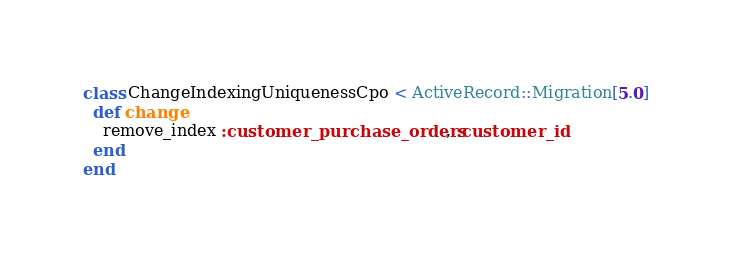<code> <loc_0><loc_0><loc_500><loc_500><_Ruby_>class ChangeIndexingUniquenessCpo < ActiveRecord::Migration[5.0]
  def change
    remove_index :customer_purchase_orders, :customer_id
  end
end
</code> 